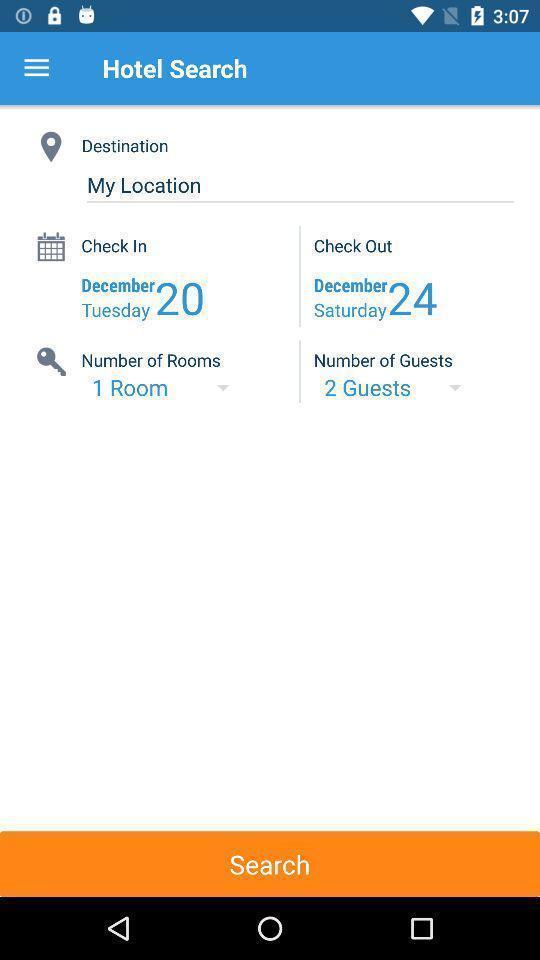Provide a description of this screenshot. Screen showing details in hotel search. 